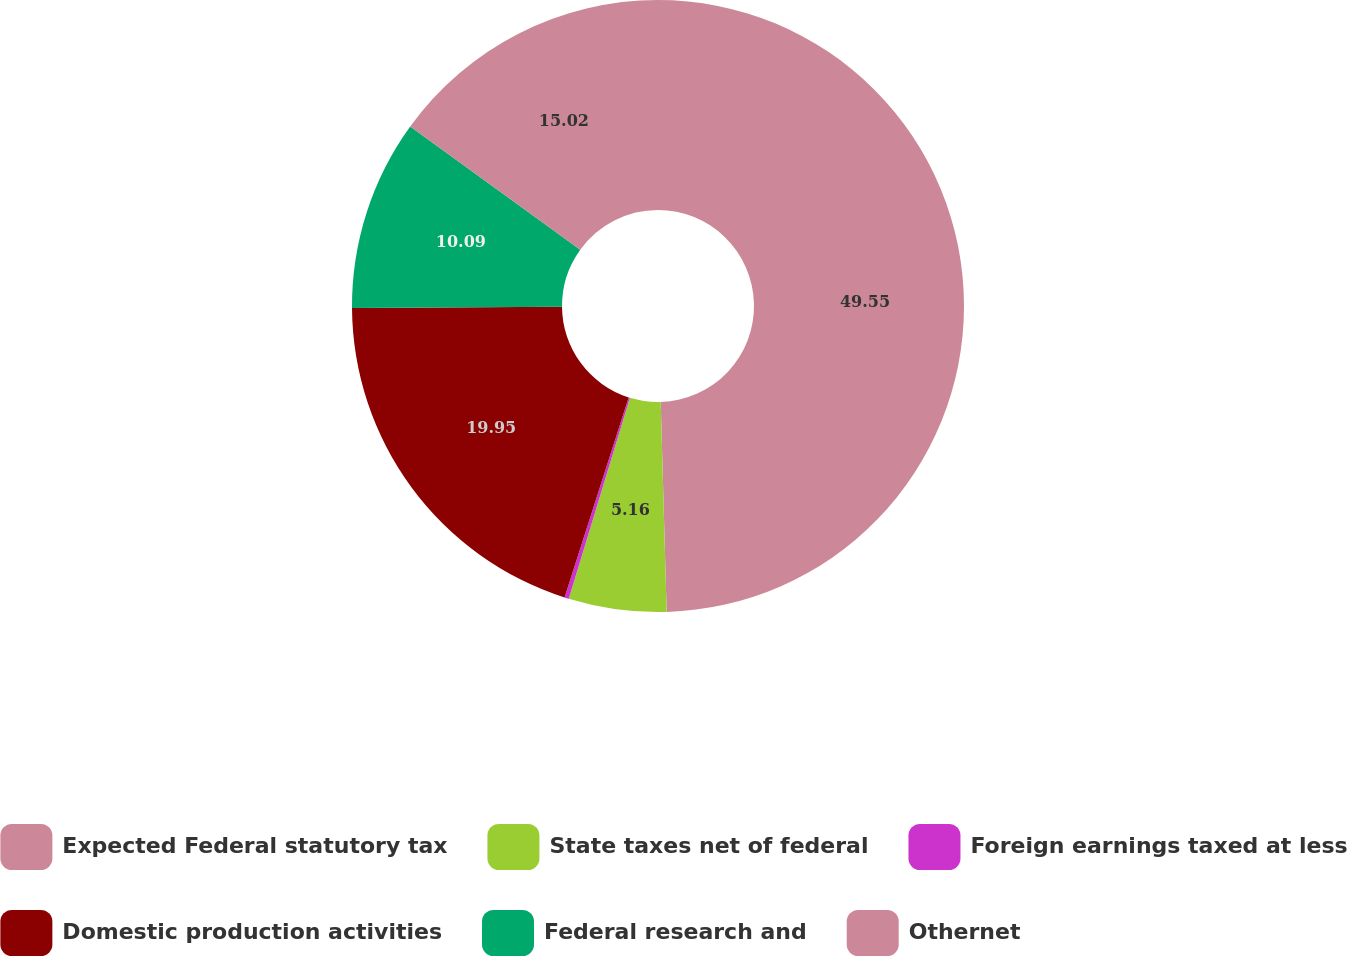Convert chart. <chart><loc_0><loc_0><loc_500><loc_500><pie_chart><fcel>Expected Federal statutory tax<fcel>State taxes net of federal<fcel>Foreign earnings taxed at less<fcel>Domestic production activities<fcel>Federal research and<fcel>Othernet<nl><fcel>49.55%<fcel>5.16%<fcel>0.23%<fcel>19.95%<fcel>10.09%<fcel>15.02%<nl></chart> 